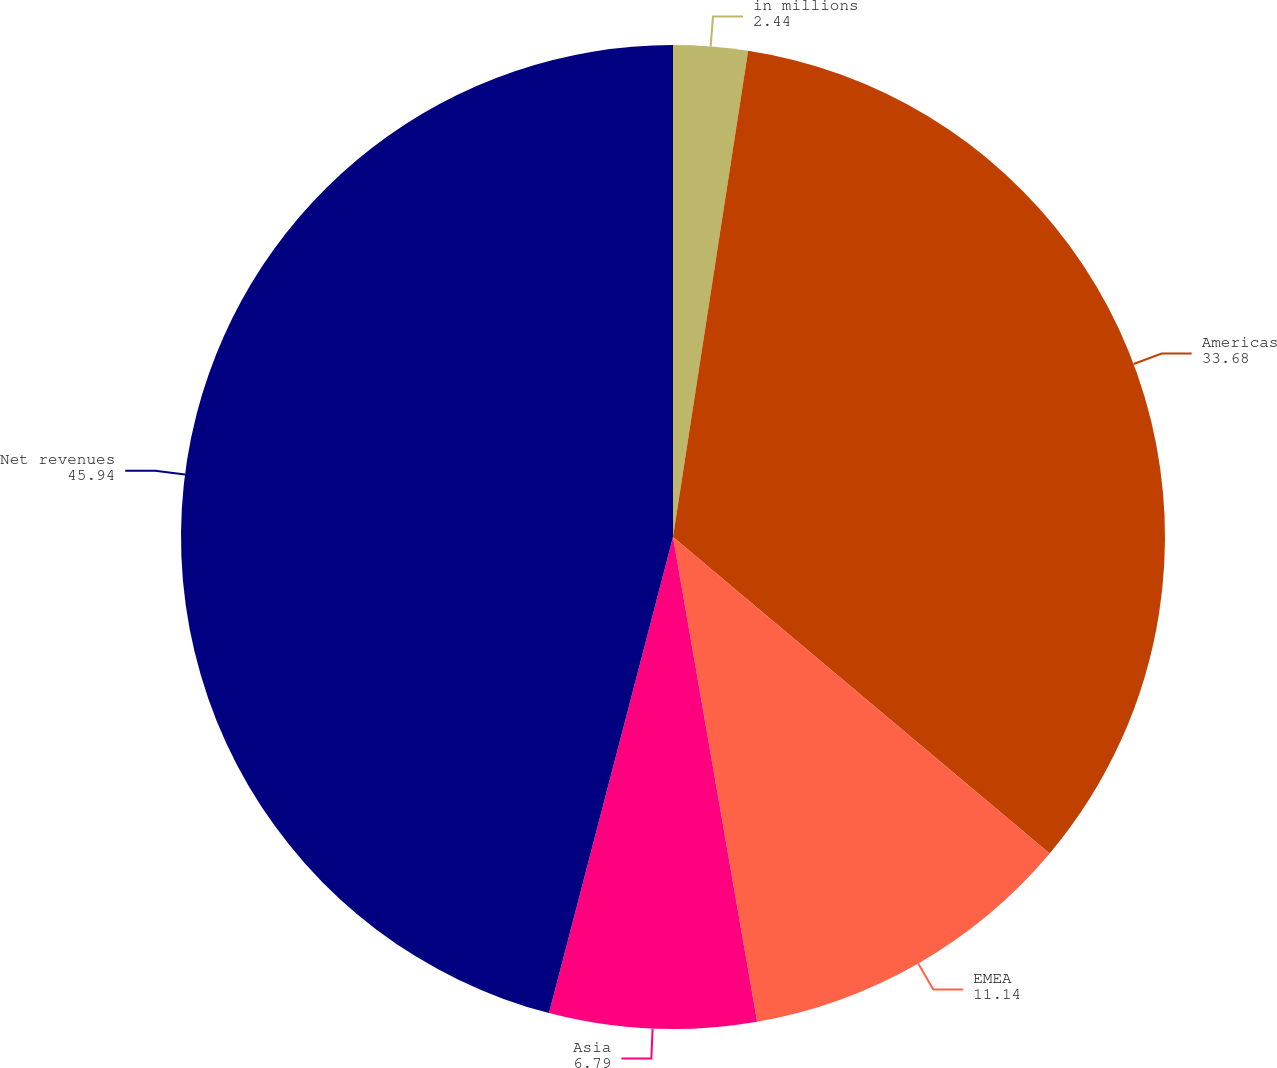Convert chart to OTSL. <chart><loc_0><loc_0><loc_500><loc_500><pie_chart><fcel>in millions<fcel>Americas<fcel>EMEA<fcel>Asia<fcel>Net revenues<nl><fcel>2.44%<fcel>33.68%<fcel>11.14%<fcel>6.79%<fcel>45.94%<nl></chart> 